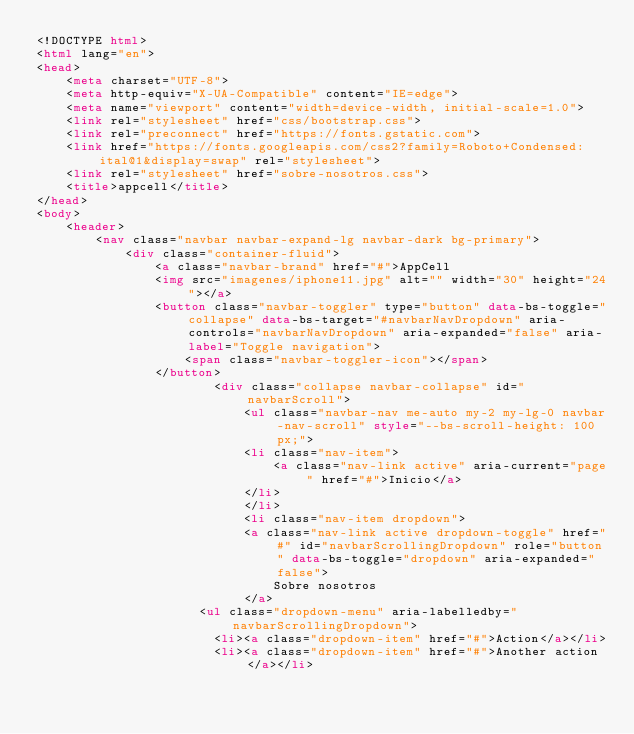Convert code to text. <code><loc_0><loc_0><loc_500><loc_500><_HTML_><!DOCTYPE html>
<html lang="en">
<head>
    <meta charset="UTF-8">
    <meta http-equiv="X-UA-Compatible" content="IE=edge">
    <meta name="viewport" content="width=device-width, initial-scale=1.0">
    <link rel="stylesheet" href="css/bootstrap.css">
    <link rel="preconnect" href="https://fonts.gstatic.com">
    <link href="https://fonts.googleapis.com/css2?family=Roboto+Condensed:ital@1&display=swap" rel="stylesheet">
    <link rel="stylesheet" href="sobre-nosotros.css">
    <title>appcell</title>
</head>
<body>
    <header>
        <nav class="navbar navbar-expand-lg navbar-dark bg-primary">
            <div class="container-fluid">
                <a class="navbar-brand" href="#">AppCell
                <img src="imagenes/iphone11.jpg" alt="" width="30" height="24"></a>
                <button class="navbar-toggler" type="button" data-bs-toggle="collapse" data-bs-target="#navbarNavDropdown" aria-controls="navbarNavDropdown" aria-expanded="false" aria-label="Toggle navigation">
                    <span class="navbar-toggler-icon"></span>
                </button>
                        <div class="collapse navbar-collapse" id="navbarScroll">
                            <ul class="navbar-nav me-auto my-2 my-lg-0 navbar-nav-scroll" style="--bs-scroll-height: 100px;">
                            <li class="nav-item">
                                <a class="nav-link active" aria-current="page" href="#">Inicio</a>
                            </li>
                            </li>
                            <li class="nav-item dropdown">
                            <a class="nav-link active dropdown-toggle" href="#" id="navbarScrollingDropdown" role="button" data-bs-toggle="dropdown" aria-expanded="false">
                                Sobre nosotros
                            </a>
                      <ul class="dropdown-menu" aria-labelledby="navbarScrollingDropdown">
                        <li><a class="dropdown-item" href="#">Action</a></li>
                        <li><a class="dropdown-item" href="#">Another action</a></li></code> 